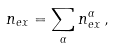Convert formula to latex. <formula><loc_0><loc_0><loc_500><loc_500>n _ { e x } = \sum _ { \alpha } n _ { e x } ^ { \alpha } \, ,</formula> 